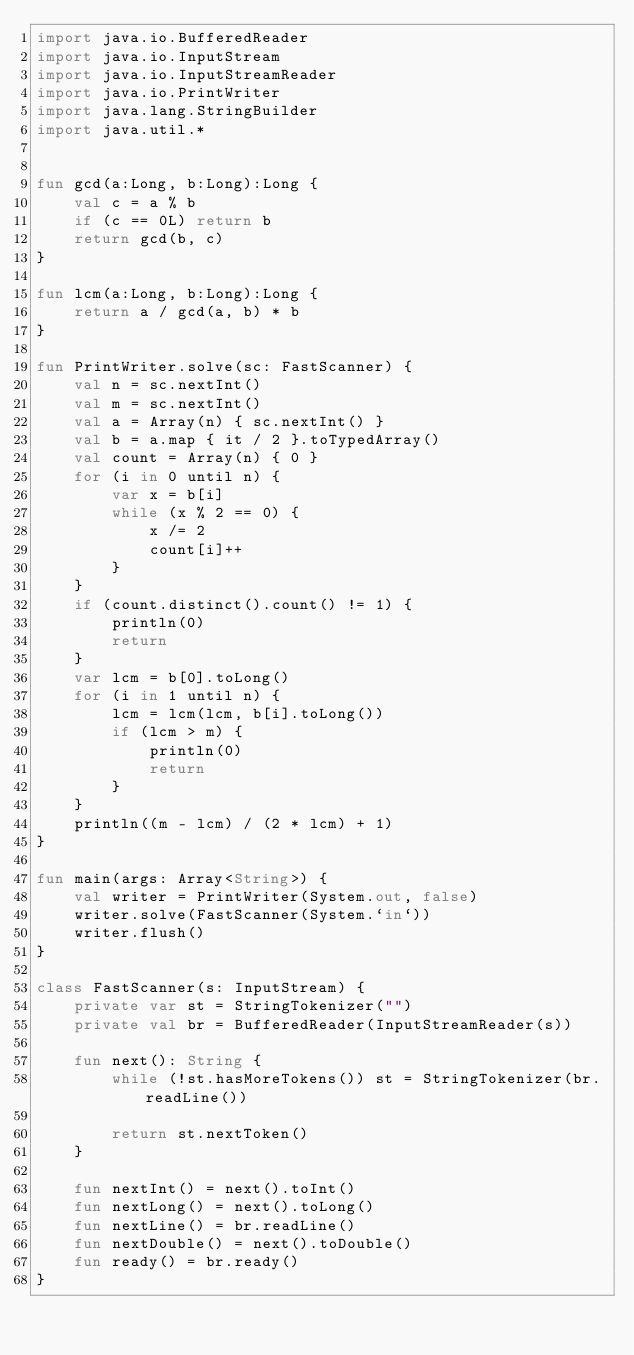<code> <loc_0><loc_0><loc_500><loc_500><_Kotlin_>import java.io.BufferedReader
import java.io.InputStream
import java.io.InputStreamReader
import java.io.PrintWriter
import java.lang.StringBuilder
import java.util.*


fun gcd(a:Long, b:Long):Long {
    val c = a % b
    if (c == 0L) return b
    return gcd(b, c)
}

fun lcm(a:Long, b:Long):Long {
    return a / gcd(a, b) * b
}

fun PrintWriter.solve(sc: FastScanner) {
    val n = sc.nextInt()
    val m = sc.nextInt()
    val a = Array(n) { sc.nextInt() }
    val b = a.map { it / 2 }.toTypedArray()
    val count = Array(n) { 0 }
    for (i in 0 until n) {
        var x = b[i]
        while (x % 2 == 0) {
            x /= 2
            count[i]++
        }
    }
    if (count.distinct().count() != 1) {
        println(0)
        return
    }
    var lcm = b[0].toLong()
    for (i in 1 until n) {
        lcm = lcm(lcm, b[i].toLong())
        if (lcm > m) {
            println(0)
            return
        }
    }
    println((m - lcm) / (2 * lcm) + 1)
}

fun main(args: Array<String>) {
    val writer = PrintWriter(System.out, false)
    writer.solve(FastScanner(System.`in`))
    writer.flush()
}

class FastScanner(s: InputStream) {
    private var st = StringTokenizer("")
    private val br = BufferedReader(InputStreamReader(s))

    fun next(): String {
        while (!st.hasMoreTokens()) st = StringTokenizer(br.readLine())

        return st.nextToken()
    }

    fun nextInt() = next().toInt()
    fun nextLong() = next().toLong()
    fun nextLine() = br.readLine()
    fun nextDouble() = next().toDouble()
    fun ready() = br.ready()
}</code> 